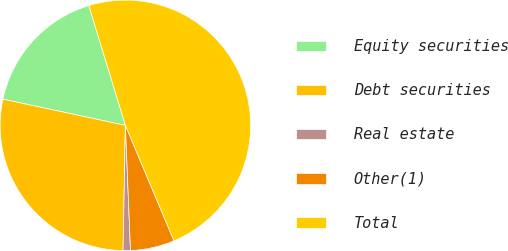Convert chart to OTSL. <chart><loc_0><loc_0><loc_500><loc_500><pie_chart><fcel>Equity securities<fcel>Debt securities<fcel>Real estate<fcel>Other(1)<fcel>Total<nl><fcel>16.93%<fcel>28.05%<fcel>0.95%<fcel>5.69%<fcel>48.37%<nl></chart> 